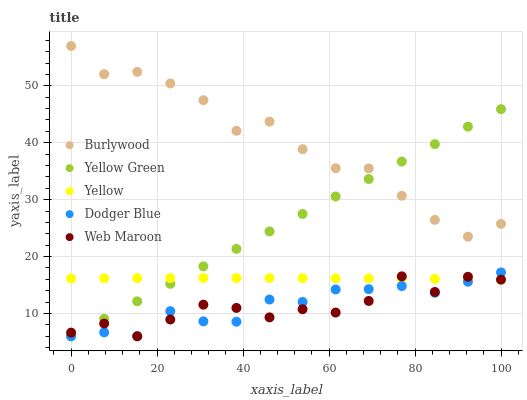Does Web Maroon have the minimum area under the curve?
Answer yes or no. Yes. Does Burlywood have the maximum area under the curve?
Answer yes or no. Yes. Does Dodger Blue have the minimum area under the curve?
Answer yes or no. No. Does Dodger Blue have the maximum area under the curve?
Answer yes or no. No. Is Yellow Green the smoothest?
Answer yes or no. Yes. Is Burlywood the roughest?
Answer yes or no. Yes. Is Web Maroon the smoothest?
Answer yes or no. No. Is Web Maroon the roughest?
Answer yes or no. No. Does Web Maroon have the lowest value?
Answer yes or no. Yes. Does Yellow have the lowest value?
Answer yes or no. No. Does Burlywood have the highest value?
Answer yes or no. Yes. Does Web Maroon have the highest value?
Answer yes or no. No. Is Dodger Blue less than Burlywood?
Answer yes or no. Yes. Is Burlywood greater than Yellow?
Answer yes or no. Yes. Does Web Maroon intersect Dodger Blue?
Answer yes or no. Yes. Is Web Maroon less than Dodger Blue?
Answer yes or no. No. Is Web Maroon greater than Dodger Blue?
Answer yes or no. No. Does Dodger Blue intersect Burlywood?
Answer yes or no. No. 